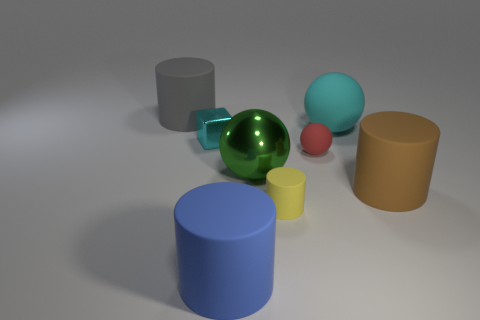What is the color of the big cylinder behind the big cyan matte ball?
Your answer should be compact. Gray. The tiny object on the left side of the small rubber thing that is in front of the big brown rubber cylinder is made of what material?
Your answer should be very brief. Metal. What is the shape of the tiny cyan object?
Ensure brevity in your answer.  Cube. What is the material of the tiny thing that is the same shape as the big cyan thing?
Give a very brief answer. Rubber. What number of brown rubber balls have the same size as the brown object?
Ensure brevity in your answer.  0. Is there a large object to the right of the large matte thing in front of the brown cylinder?
Offer a terse response. Yes. How many brown objects are shiny balls or big rubber cylinders?
Provide a short and direct response. 1. What color is the big metal object?
Keep it short and to the point. Green. What is the size of the yellow cylinder that is made of the same material as the large blue thing?
Give a very brief answer. Small. What number of green objects have the same shape as the big cyan thing?
Offer a very short reply. 1. 